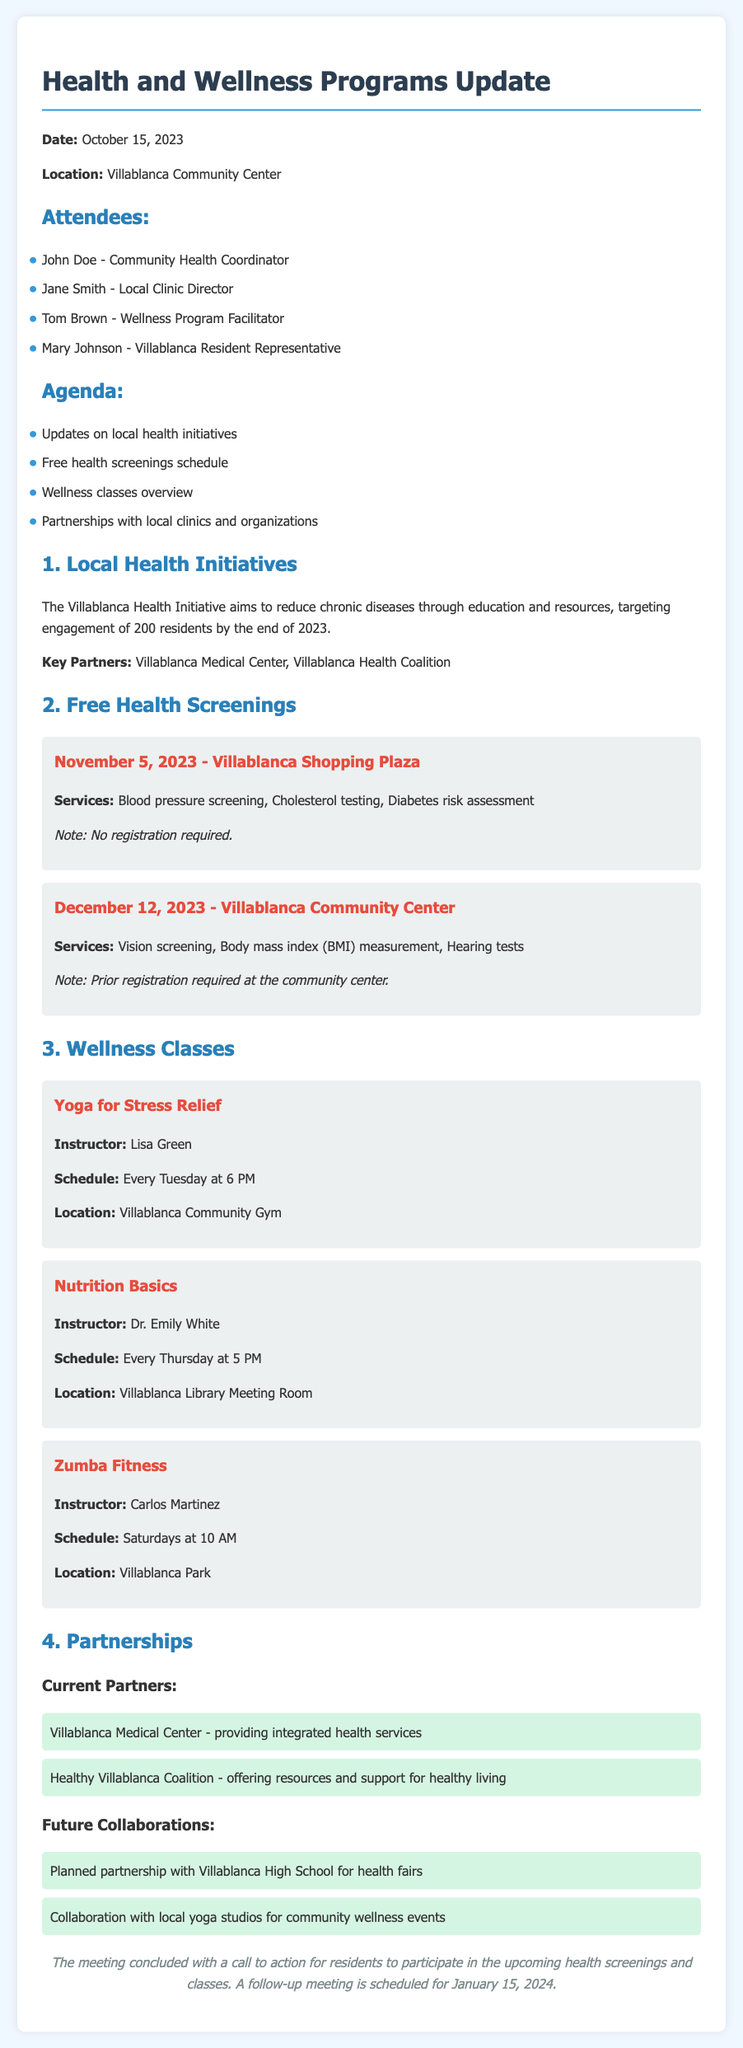What is the date of the meeting? The date of the meeting is provided at the beginning of the document.
Answer: October 15, 2023 Where is the yoga class held? The location for the yoga class is specified in the wellness class section.
Answer: Villablanca Community Gym Who is the instructor for Nutrition Basics? The instructor's name is directly mentioned in the wellness classes overview.
Answer: Dr. Emily White How many free health screenings are scheduled in 2023? The document lists two upcoming health screenings for the year 2023.
Answer: 2 What is the target number of residents for the Villablanca Health Initiative? The document states the target engagement for the health initiative.
Answer: 200 When is the follow-up meeting scheduled? The conclusion outlines the date of the follow-up meeting.
Answer: January 15, 2024 What is the primary goal of the Villablanca Health Initiative? The document describes the initiative's aim to reduce chronic diseases.
Answer: Reduce chronic diseases Which organization is providing integrated health services? The partnerships section names the organization responsible for these services.
Answer: Villablanca Medical Center What type of services are offered at the health screening on November 5, 2023? The document lists the services available on that date.
Answer: Blood pressure screening, Cholesterol testing, Diabetes risk assessment 